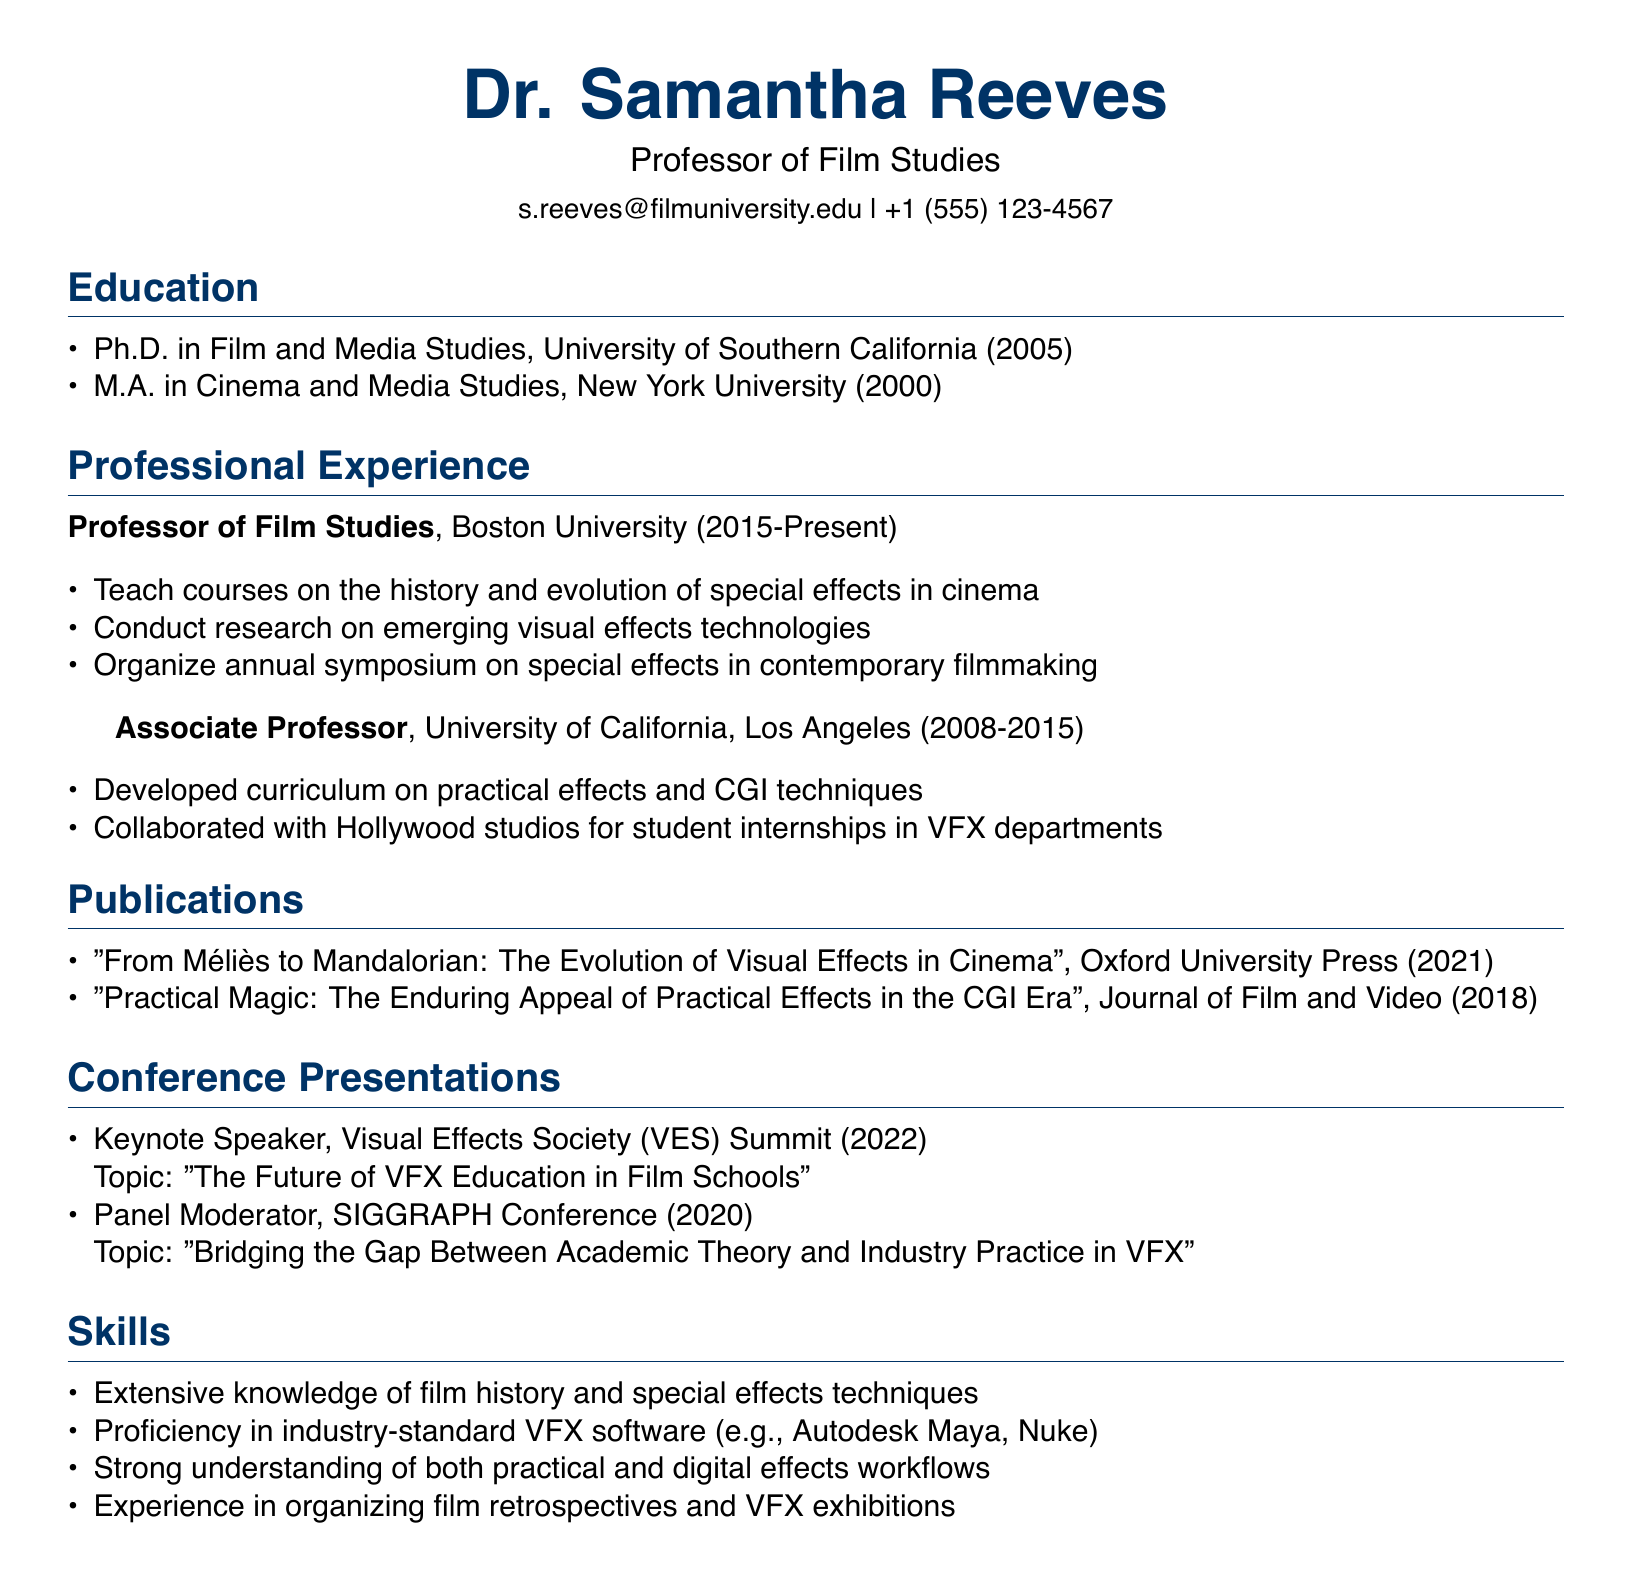What is Dr. Samantha Reeves' title? The title is specified as "Professor of Film Studies" in the document.
Answer: Professor of Film Studies Which university did Dr. Reeves obtain her Ph.D. from? The document states she earned her Ph.D. from the University of Southern California.
Answer: University of Southern California In which year did Dr. Reeves publish the book "From Méliès to Mandalorian"? The publication year of the book is clearly mentioned in the document as 2021.
Answer: 2021 What position did Dr. Reeves hold before becoming a Professor at Boston University? The document indicates she was an Associate Professor at the University of California, Los Angeles prior to her current position.
Answer: Associate Professor How many years did Dr. Reeves work at UCLA? The duration indicated in the document shows she worked from 2008 to 2015, which is 7 years.
Answer: 7 years What is one of Dr. Reeves' skills related to VFX software? The document lists her proficiency in industry-standard VFX software as one of her skills.
Answer: Autodesk Maya What type of conference role did Dr. Reeves have at the Visual Effects Society Summit? The document specifies her role as "Keynote Speaker" at the mentioned summit.
Answer: Keynote Speaker Which publication discusses the appeal of practical effects? The document mentions "Practical Magic: The Enduring Appeal of Practical Effects in the CGI Era" as the publication that addresses this subject.
Answer: Practical Magic: The Enduring Appeal of Practical Effects in the CGI Era What is a responsibility of Dr. Reeves at Boston University? The document states one responsibility is to teach courses on the history and evolution of special effects in cinema.
Answer: Teach courses on the history and evolution of special effects in cinema 